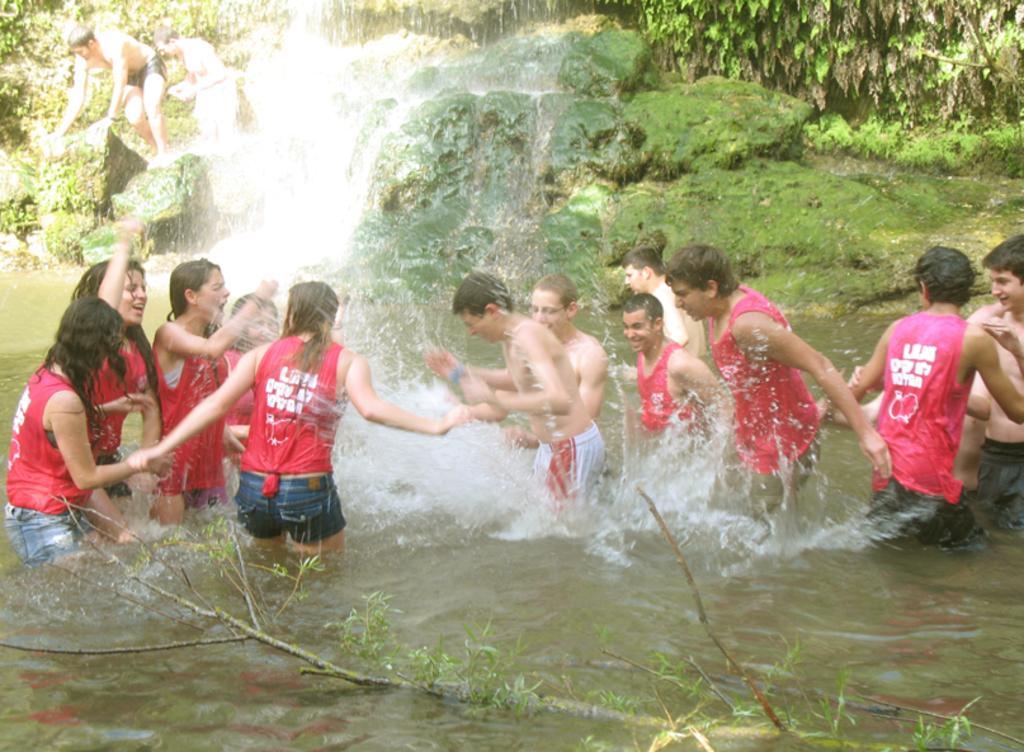In one or two sentences, can you explain what this image depicts? In this image we can see a group of people playing in the water. Here we can see the waterfall at the top. Here we can see the grass on the rocks. Here we can see the branch of a tree in the water. Here we can see the leaves on the top right side. 